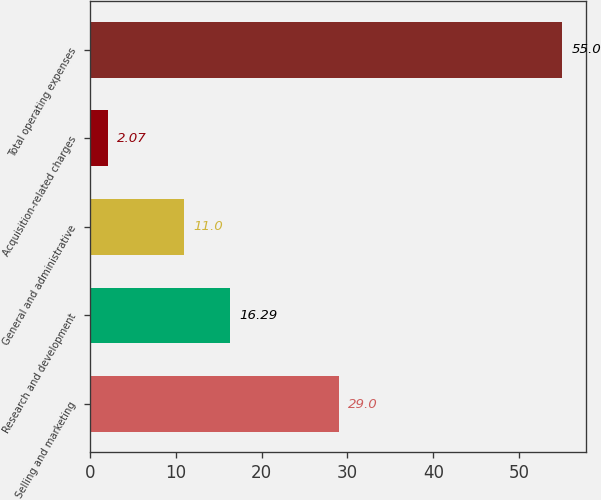<chart> <loc_0><loc_0><loc_500><loc_500><bar_chart><fcel>Selling and marketing<fcel>Research and development<fcel>General and administrative<fcel>Acquisition-related charges<fcel>Total operating expenses<nl><fcel>29<fcel>16.29<fcel>11<fcel>2.07<fcel>55<nl></chart> 